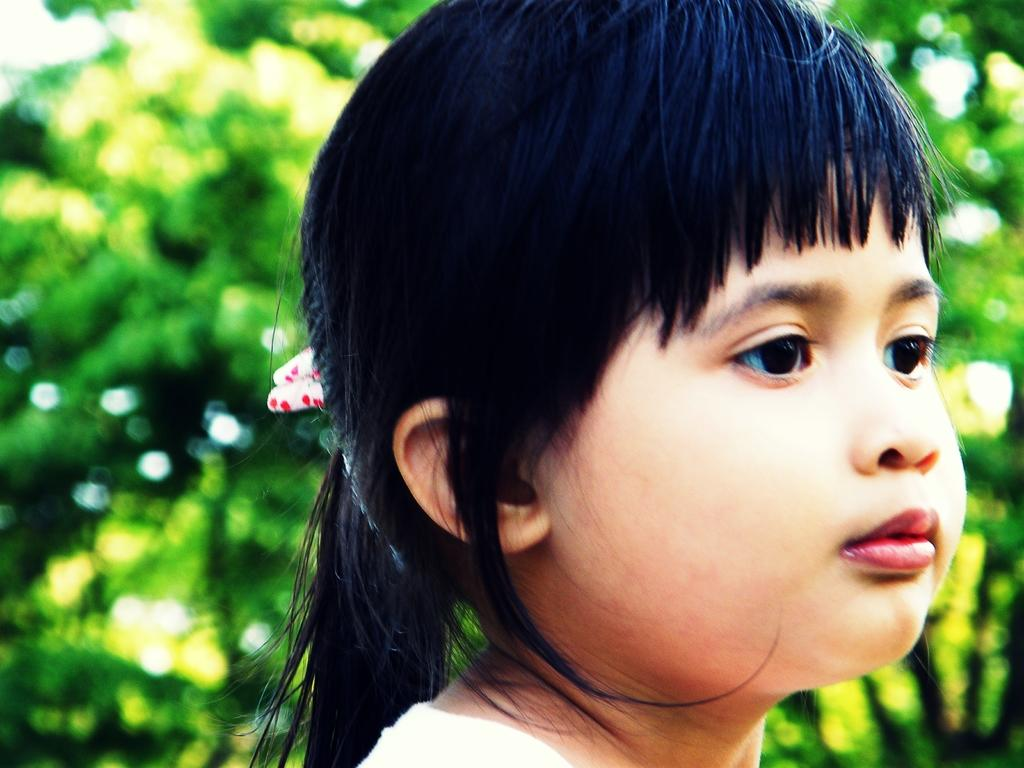What is the main subject of the image? There is a child in the image. Can you describe the background of the image? The background of the image is blurry. What type of smoke can be seen coming from the child's sock in the image? There is no smoke or sock present in the image; it features a child with a blurry background. 